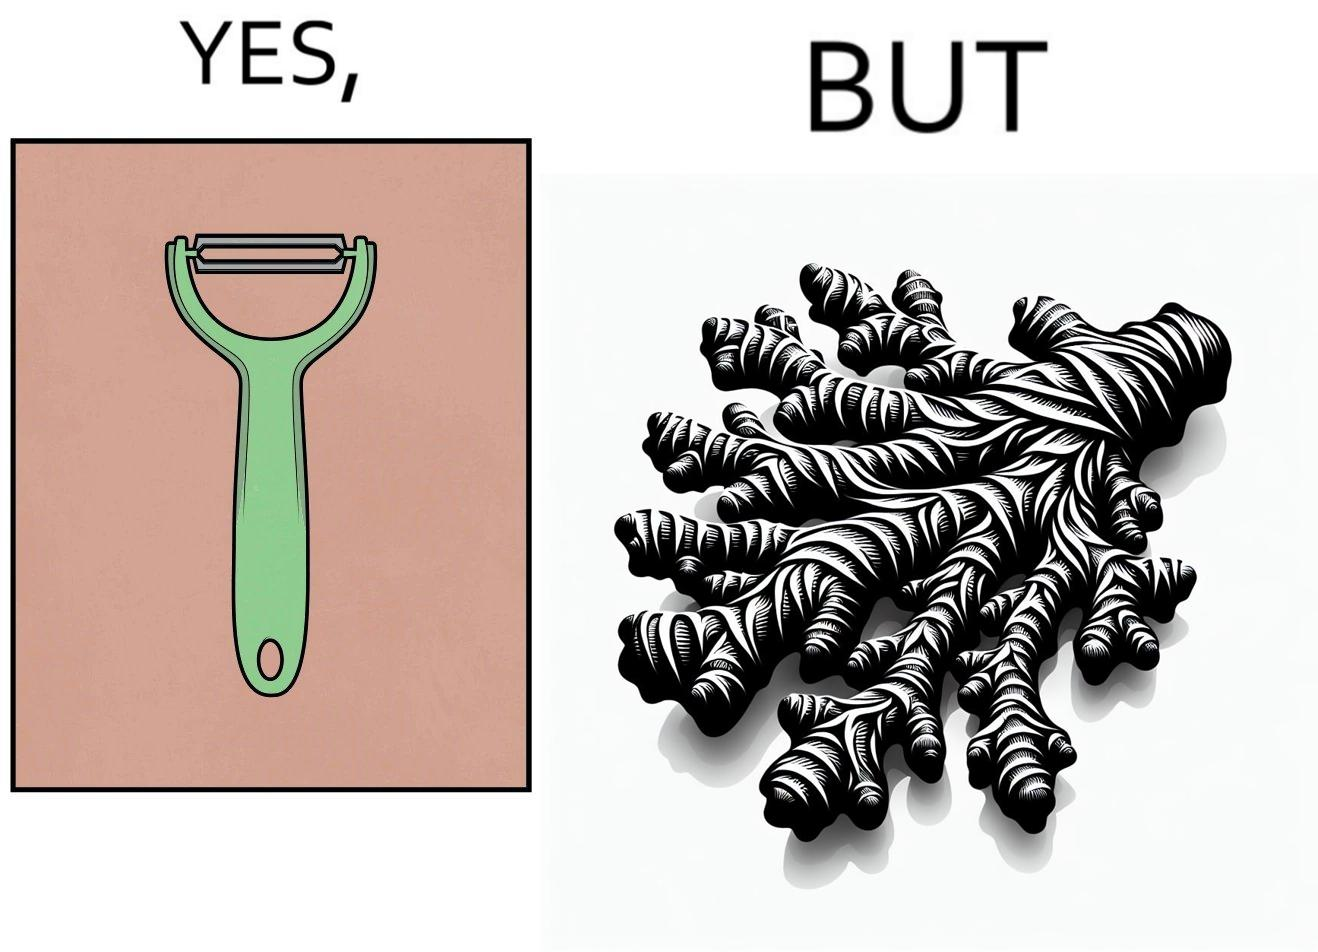Describe the content of this image. The image is funny because it suggests that while we have peelers to peel off the skin of many different fruits and vegetables, it is useless against a ginger which has a very complicated shape. 